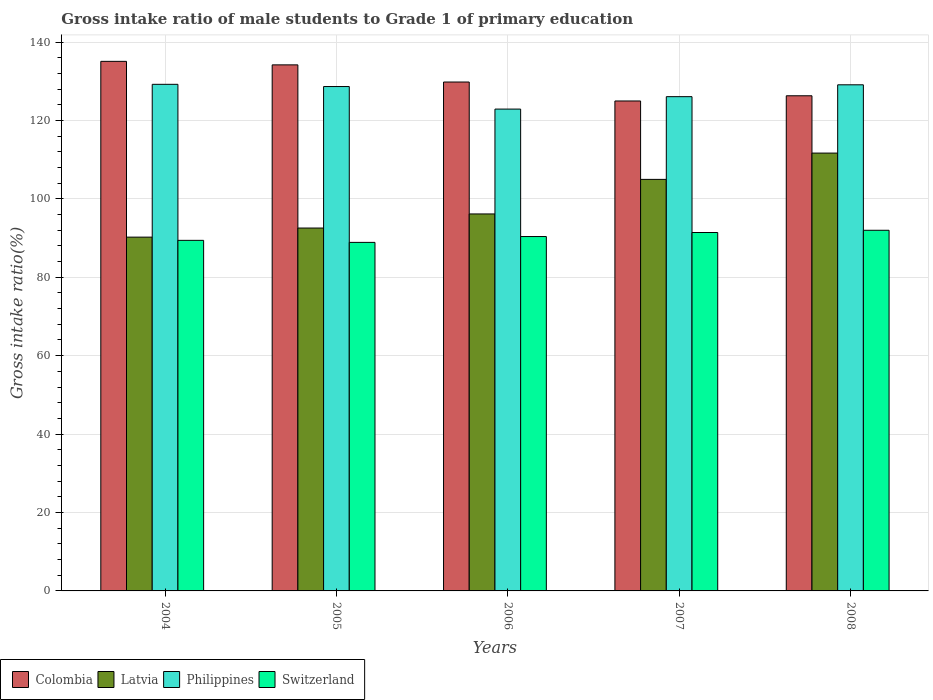Are the number of bars per tick equal to the number of legend labels?
Your answer should be compact. Yes. Are the number of bars on each tick of the X-axis equal?
Provide a succinct answer. Yes. How many bars are there on the 3rd tick from the right?
Ensure brevity in your answer.  4. What is the gross intake ratio in Latvia in 2006?
Provide a short and direct response. 96.15. Across all years, what is the maximum gross intake ratio in Colombia?
Offer a terse response. 135.07. Across all years, what is the minimum gross intake ratio in Colombia?
Offer a very short reply. 124.96. What is the total gross intake ratio in Colombia in the graph?
Provide a succinct answer. 650.29. What is the difference between the gross intake ratio in Latvia in 2006 and that in 2008?
Provide a short and direct response. -15.52. What is the difference between the gross intake ratio in Switzerland in 2007 and the gross intake ratio in Philippines in 2006?
Offer a very short reply. -31.48. What is the average gross intake ratio in Colombia per year?
Make the answer very short. 130.06. In the year 2005, what is the difference between the gross intake ratio in Latvia and gross intake ratio in Colombia?
Offer a terse response. -41.62. In how many years, is the gross intake ratio in Philippines greater than 32 %?
Make the answer very short. 5. What is the ratio of the gross intake ratio in Colombia in 2005 to that in 2007?
Give a very brief answer. 1.07. What is the difference between the highest and the second highest gross intake ratio in Colombia?
Your answer should be very brief. 0.9. What is the difference between the highest and the lowest gross intake ratio in Colombia?
Your answer should be compact. 10.11. In how many years, is the gross intake ratio in Switzerland greater than the average gross intake ratio in Switzerland taken over all years?
Give a very brief answer. 2. What does the 3rd bar from the left in 2005 represents?
Your answer should be compact. Philippines. What does the 1st bar from the right in 2006 represents?
Keep it short and to the point. Switzerland. How many bars are there?
Provide a short and direct response. 20. Are all the bars in the graph horizontal?
Your response must be concise. No. Are the values on the major ticks of Y-axis written in scientific E-notation?
Your answer should be very brief. No. Does the graph contain any zero values?
Give a very brief answer. No. What is the title of the graph?
Your response must be concise. Gross intake ratio of male students to Grade 1 of primary education. Does "China" appear as one of the legend labels in the graph?
Your answer should be very brief. No. What is the label or title of the X-axis?
Offer a terse response. Years. What is the label or title of the Y-axis?
Give a very brief answer. Gross intake ratio(%). What is the Gross intake ratio(%) of Colombia in 2004?
Your answer should be compact. 135.07. What is the Gross intake ratio(%) in Latvia in 2004?
Keep it short and to the point. 90.24. What is the Gross intake ratio(%) in Philippines in 2004?
Make the answer very short. 129.21. What is the Gross intake ratio(%) of Switzerland in 2004?
Keep it short and to the point. 89.42. What is the Gross intake ratio(%) in Colombia in 2005?
Make the answer very short. 134.17. What is the Gross intake ratio(%) in Latvia in 2005?
Provide a short and direct response. 92.55. What is the Gross intake ratio(%) of Philippines in 2005?
Your answer should be compact. 128.65. What is the Gross intake ratio(%) in Switzerland in 2005?
Ensure brevity in your answer.  88.9. What is the Gross intake ratio(%) in Colombia in 2006?
Offer a terse response. 129.8. What is the Gross intake ratio(%) of Latvia in 2006?
Offer a very short reply. 96.15. What is the Gross intake ratio(%) in Philippines in 2006?
Keep it short and to the point. 122.89. What is the Gross intake ratio(%) in Switzerland in 2006?
Give a very brief answer. 90.39. What is the Gross intake ratio(%) in Colombia in 2007?
Your response must be concise. 124.96. What is the Gross intake ratio(%) in Latvia in 2007?
Offer a terse response. 104.97. What is the Gross intake ratio(%) of Philippines in 2007?
Ensure brevity in your answer.  126.06. What is the Gross intake ratio(%) in Switzerland in 2007?
Keep it short and to the point. 91.42. What is the Gross intake ratio(%) of Colombia in 2008?
Your response must be concise. 126.29. What is the Gross intake ratio(%) of Latvia in 2008?
Your response must be concise. 111.67. What is the Gross intake ratio(%) in Philippines in 2008?
Ensure brevity in your answer.  129.09. What is the Gross intake ratio(%) of Switzerland in 2008?
Your response must be concise. 91.99. Across all years, what is the maximum Gross intake ratio(%) of Colombia?
Ensure brevity in your answer.  135.07. Across all years, what is the maximum Gross intake ratio(%) of Latvia?
Ensure brevity in your answer.  111.67. Across all years, what is the maximum Gross intake ratio(%) of Philippines?
Provide a short and direct response. 129.21. Across all years, what is the maximum Gross intake ratio(%) in Switzerland?
Ensure brevity in your answer.  91.99. Across all years, what is the minimum Gross intake ratio(%) of Colombia?
Your answer should be compact. 124.96. Across all years, what is the minimum Gross intake ratio(%) in Latvia?
Offer a terse response. 90.24. Across all years, what is the minimum Gross intake ratio(%) of Philippines?
Offer a very short reply. 122.89. Across all years, what is the minimum Gross intake ratio(%) of Switzerland?
Your answer should be very brief. 88.9. What is the total Gross intake ratio(%) in Colombia in the graph?
Your answer should be very brief. 650.29. What is the total Gross intake ratio(%) in Latvia in the graph?
Ensure brevity in your answer.  495.58. What is the total Gross intake ratio(%) in Philippines in the graph?
Make the answer very short. 635.9. What is the total Gross intake ratio(%) in Switzerland in the graph?
Your response must be concise. 452.1. What is the difference between the Gross intake ratio(%) of Colombia in 2004 and that in 2005?
Make the answer very short. 0.9. What is the difference between the Gross intake ratio(%) in Latvia in 2004 and that in 2005?
Your answer should be compact. -2.32. What is the difference between the Gross intake ratio(%) in Philippines in 2004 and that in 2005?
Provide a succinct answer. 0.57. What is the difference between the Gross intake ratio(%) in Switzerland in 2004 and that in 2005?
Offer a terse response. 0.52. What is the difference between the Gross intake ratio(%) in Colombia in 2004 and that in 2006?
Offer a terse response. 5.27. What is the difference between the Gross intake ratio(%) in Latvia in 2004 and that in 2006?
Offer a very short reply. -5.91. What is the difference between the Gross intake ratio(%) in Philippines in 2004 and that in 2006?
Your answer should be very brief. 6.32. What is the difference between the Gross intake ratio(%) in Switzerland in 2004 and that in 2006?
Provide a succinct answer. -0.97. What is the difference between the Gross intake ratio(%) of Colombia in 2004 and that in 2007?
Provide a succinct answer. 10.11. What is the difference between the Gross intake ratio(%) in Latvia in 2004 and that in 2007?
Your answer should be compact. -14.73. What is the difference between the Gross intake ratio(%) of Philippines in 2004 and that in 2007?
Provide a short and direct response. 3.15. What is the difference between the Gross intake ratio(%) in Switzerland in 2004 and that in 2007?
Offer a very short reply. -2. What is the difference between the Gross intake ratio(%) in Colombia in 2004 and that in 2008?
Ensure brevity in your answer.  8.78. What is the difference between the Gross intake ratio(%) of Latvia in 2004 and that in 2008?
Make the answer very short. -21.44. What is the difference between the Gross intake ratio(%) of Philippines in 2004 and that in 2008?
Your response must be concise. 0.13. What is the difference between the Gross intake ratio(%) in Switzerland in 2004 and that in 2008?
Keep it short and to the point. -2.57. What is the difference between the Gross intake ratio(%) in Colombia in 2005 and that in 2006?
Make the answer very short. 4.38. What is the difference between the Gross intake ratio(%) of Latvia in 2005 and that in 2006?
Ensure brevity in your answer.  -3.6. What is the difference between the Gross intake ratio(%) of Philippines in 2005 and that in 2006?
Give a very brief answer. 5.75. What is the difference between the Gross intake ratio(%) in Switzerland in 2005 and that in 2006?
Provide a short and direct response. -1.49. What is the difference between the Gross intake ratio(%) in Colombia in 2005 and that in 2007?
Your answer should be compact. 9.21. What is the difference between the Gross intake ratio(%) in Latvia in 2005 and that in 2007?
Provide a succinct answer. -12.41. What is the difference between the Gross intake ratio(%) in Philippines in 2005 and that in 2007?
Your answer should be very brief. 2.58. What is the difference between the Gross intake ratio(%) of Switzerland in 2005 and that in 2007?
Offer a very short reply. -2.52. What is the difference between the Gross intake ratio(%) in Colombia in 2005 and that in 2008?
Offer a terse response. 7.88. What is the difference between the Gross intake ratio(%) in Latvia in 2005 and that in 2008?
Give a very brief answer. -19.12. What is the difference between the Gross intake ratio(%) in Philippines in 2005 and that in 2008?
Ensure brevity in your answer.  -0.44. What is the difference between the Gross intake ratio(%) in Switzerland in 2005 and that in 2008?
Your response must be concise. -3.09. What is the difference between the Gross intake ratio(%) of Colombia in 2006 and that in 2007?
Keep it short and to the point. 4.83. What is the difference between the Gross intake ratio(%) in Latvia in 2006 and that in 2007?
Ensure brevity in your answer.  -8.82. What is the difference between the Gross intake ratio(%) in Philippines in 2006 and that in 2007?
Your answer should be very brief. -3.17. What is the difference between the Gross intake ratio(%) of Switzerland in 2006 and that in 2007?
Your answer should be compact. -1.03. What is the difference between the Gross intake ratio(%) in Colombia in 2006 and that in 2008?
Offer a terse response. 3.5. What is the difference between the Gross intake ratio(%) of Latvia in 2006 and that in 2008?
Offer a very short reply. -15.52. What is the difference between the Gross intake ratio(%) in Philippines in 2006 and that in 2008?
Your answer should be compact. -6.19. What is the difference between the Gross intake ratio(%) in Switzerland in 2006 and that in 2008?
Give a very brief answer. -1.6. What is the difference between the Gross intake ratio(%) in Colombia in 2007 and that in 2008?
Your response must be concise. -1.33. What is the difference between the Gross intake ratio(%) in Latvia in 2007 and that in 2008?
Provide a short and direct response. -6.71. What is the difference between the Gross intake ratio(%) in Philippines in 2007 and that in 2008?
Keep it short and to the point. -3.02. What is the difference between the Gross intake ratio(%) of Switzerland in 2007 and that in 2008?
Your answer should be very brief. -0.57. What is the difference between the Gross intake ratio(%) of Colombia in 2004 and the Gross intake ratio(%) of Latvia in 2005?
Ensure brevity in your answer.  42.52. What is the difference between the Gross intake ratio(%) of Colombia in 2004 and the Gross intake ratio(%) of Philippines in 2005?
Your answer should be compact. 6.42. What is the difference between the Gross intake ratio(%) of Colombia in 2004 and the Gross intake ratio(%) of Switzerland in 2005?
Give a very brief answer. 46.17. What is the difference between the Gross intake ratio(%) of Latvia in 2004 and the Gross intake ratio(%) of Philippines in 2005?
Offer a very short reply. -38.41. What is the difference between the Gross intake ratio(%) in Latvia in 2004 and the Gross intake ratio(%) in Switzerland in 2005?
Offer a terse response. 1.34. What is the difference between the Gross intake ratio(%) of Philippines in 2004 and the Gross intake ratio(%) of Switzerland in 2005?
Provide a succinct answer. 40.31. What is the difference between the Gross intake ratio(%) in Colombia in 2004 and the Gross intake ratio(%) in Latvia in 2006?
Give a very brief answer. 38.92. What is the difference between the Gross intake ratio(%) of Colombia in 2004 and the Gross intake ratio(%) of Philippines in 2006?
Make the answer very short. 12.18. What is the difference between the Gross intake ratio(%) of Colombia in 2004 and the Gross intake ratio(%) of Switzerland in 2006?
Offer a very short reply. 44.68. What is the difference between the Gross intake ratio(%) in Latvia in 2004 and the Gross intake ratio(%) in Philippines in 2006?
Give a very brief answer. -32.66. What is the difference between the Gross intake ratio(%) of Latvia in 2004 and the Gross intake ratio(%) of Switzerland in 2006?
Your answer should be very brief. -0.15. What is the difference between the Gross intake ratio(%) of Philippines in 2004 and the Gross intake ratio(%) of Switzerland in 2006?
Make the answer very short. 38.83. What is the difference between the Gross intake ratio(%) in Colombia in 2004 and the Gross intake ratio(%) in Latvia in 2007?
Your response must be concise. 30.1. What is the difference between the Gross intake ratio(%) of Colombia in 2004 and the Gross intake ratio(%) of Philippines in 2007?
Ensure brevity in your answer.  9.01. What is the difference between the Gross intake ratio(%) in Colombia in 2004 and the Gross intake ratio(%) in Switzerland in 2007?
Your answer should be very brief. 43.65. What is the difference between the Gross intake ratio(%) of Latvia in 2004 and the Gross intake ratio(%) of Philippines in 2007?
Ensure brevity in your answer.  -35.83. What is the difference between the Gross intake ratio(%) in Latvia in 2004 and the Gross intake ratio(%) in Switzerland in 2007?
Offer a terse response. -1.18. What is the difference between the Gross intake ratio(%) in Philippines in 2004 and the Gross intake ratio(%) in Switzerland in 2007?
Provide a succinct answer. 37.8. What is the difference between the Gross intake ratio(%) in Colombia in 2004 and the Gross intake ratio(%) in Latvia in 2008?
Offer a very short reply. 23.4. What is the difference between the Gross intake ratio(%) of Colombia in 2004 and the Gross intake ratio(%) of Philippines in 2008?
Your answer should be compact. 5.98. What is the difference between the Gross intake ratio(%) in Colombia in 2004 and the Gross intake ratio(%) in Switzerland in 2008?
Provide a succinct answer. 43.08. What is the difference between the Gross intake ratio(%) in Latvia in 2004 and the Gross intake ratio(%) in Philippines in 2008?
Offer a very short reply. -38.85. What is the difference between the Gross intake ratio(%) of Latvia in 2004 and the Gross intake ratio(%) of Switzerland in 2008?
Provide a succinct answer. -1.75. What is the difference between the Gross intake ratio(%) of Philippines in 2004 and the Gross intake ratio(%) of Switzerland in 2008?
Offer a very short reply. 37.23. What is the difference between the Gross intake ratio(%) of Colombia in 2005 and the Gross intake ratio(%) of Latvia in 2006?
Your answer should be compact. 38.02. What is the difference between the Gross intake ratio(%) in Colombia in 2005 and the Gross intake ratio(%) in Philippines in 2006?
Make the answer very short. 11.28. What is the difference between the Gross intake ratio(%) in Colombia in 2005 and the Gross intake ratio(%) in Switzerland in 2006?
Your answer should be very brief. 43.78. What is the difference between the Gross intake ratio(%) in Latvia in 2005 and the Gross intake ratio(%) in Philippines in 2006?
Offer a very short reply. -30.34. What is the difference between the Gross intake ratio(%) in Latvia in 2005 and the Gross intake ratio(%) in Switzerland in 2006?
Offer a very short reply. 2.17. What is the difference between the Gross intake ratio(%) of Philippines in 2005 and the Gross intake ratio(%) of Switzerland in 2006?
Your response must be concise. 38.26. What is the difference between the Gross intake ratio(%) of Colombia in 2005 and the Gross intake ratio(%) of Latvia in 2007?
Offer a terse response. 29.2. What is the difference between the Gross intake ratio(%) in Colombia in 2005 and the Gross intake ratio(%) in Philippines in 2007?
Your answer should be compact. 8.11. What is the difference between the Gross intake ratio(%) of Colombia in 2005 and the Gross intake ratio(%) of Switzerland in 2007?
Make the answer very short. 42.75. What is the difference between the Gross intake ratio(%) in Latvia in 2005 and the Gross intake ratio(%) in Philippines in 2007?
Provide a succinct answer. -33.51. What is the difference between the Gross intake ratio(%) of Latvia in 2005 and the Gross intake ratio(%) of Switzerland in 2007?
Keep it short and to the point. 1.14. What is the difference between the Gross intake ratio(%) in Philippines in 2005 and the Gross intake ratio(%) in Switzerland in 2007?
Make the answer very short. 37.23. What is the difference between the Gross intake ratio(%) of Colombia in 2005 and the Gross intake ratio(%) of Latvia in 2008?
Make the answer very short. 22.5. What is the difference between the Gross intake ratio(%) in Colombia in 2005 and the Gross intake ratio(%) in Philippines in 2008?
Your answer should be very brief. 5.08. What is the difference between the Gross intake ratio(%) in Colombia in 2005 and the Gross intake ratio(%) in Switzerland in 2008?
Provide a succinct answer. 42.18. What is the difference between the Gross intake ratio(%) of Latvia in 2005 and the Gross intake ratio(%) of Philippines in 2008?
Ensure brevity in your answer.  -36.53. What is the difference between the Gross intake ratio(%) in Latvia in 2005 and the Gross intake ratio(%) in Switzerland in 2008?
Give a very brief answer. 0.57. What is the difference between the Gross intake ratio(%) in Philippines in 2005 and the Gross intake ratio(%) in Switzerland in 2008?
Keep it short and to the point. 36.66. What is the difference between the Gross intake ratio(%) in Colombia in 2006 and the Gross intake ratio(%) in Latvia in 2007?
Offer a terse response. 24.83. What is the difference between the Gross intake ratio(%) of Colombia in 2006 and the Gross intake ratio(%) of Philippines in 2007?
Your answer should be compact. 3.73. What is the difference between the Gross intake ratio(%) of Colombia in 2006 and the Gross intake ratio(%) of Switzerland in 2007?
Give a very brief answer. 38.38. What is the difference between the Gross intake ratio(%) in Latvia in 2006 and the Gross intake ratio(%) in Philippines in 2007?
Provide a short and direct response. -29.91. What is the difference between the Gross intake ratio(%) in Latvia in 2006 and the Gross intake ratio(%) in Switzerland in 2007?
Provide a succinct answer. 4.73. What is the difference between the Gross intake ratio(%) in Philippines in 2006 and the Gross intake ratio(%) in Switzerland in 2007?
Give a very brief answer. 31.48. What is the difference between the Gross intake ratio(%) of Colombia in 2006 and the Gross intake ratio(%) of Latvia in 2008?
Provide a short and direct response. 18.12. What is the difference between the Gross intake ratio(%) of Colombia in 2006 and the Gross intake ratio(%) of Philippines in 2008?
Offer a terse response. 0.71. What is the difference between the Gross intake ratio(%) of Colombia in 2006 and the Gross intake ratio(%) of Switzerland in 2008?
Your answer should be very brief. 37.81. What is the difference between the Gross intake ratio(%) of Latvia in 2006 and the Gross intake ratio(%) of Philippines in 2008?
Provide a short and direct response. -32.94. What is the difference between the Gross intake ratio(%) in Latvia in 2006 and the Gross intake ratio(%) in Switzerland in 2008?
Give a very brief answer. 4.16. What is the difference between the Gross intake ratio(%) in Philippines in 2006 and the Gross intake ratio(%) in Switzerland in 2008?
Your answer should be very brief. 30.91. What is the difference between the Gross intake ratio(%) in Colombia in 2007 and the Gross intake ratio(%) in Latvia in 2008?
Your response must be concise. 13.29. What is the difference between the Gross intake ratio(%) in Colombia in 2007 and the Gross intake ratio(%) in Philippines in 2008?
Make the answer very short. -4.12. What is the difference between the Gross intake ratio(%) in Colombia in 2007 and the Gross intake ratio(%) in Switzerland in 2008?
Make the answer very short. 32.97. What is the difference between the Gross intake ratio(%) in Latvia in 2007 and the Gross intake ratio(%) in Philippines in 2008?
Ensure brevity in your answer.  -24.12. What is the difference between the Gross intake ratio(%) of Latvia in 2007 and the Gross intake ratio(%) of Switzerland in 2008?
Ensure brevity in your answer.  12.98. What is the difference between the Gross intake ratio(%) in Philippines in 2007 and the Gross intake ratio(%) in Switzerland in 2008?
Provide a short and direct response. 34.08. What is the average Gross intake ratio(%) in Colombia per year?
Make the answer very short. 130.06. What is the average Gross intake ratio(%) of Latvia per year?
Your answer should be compact. 99.12. What is the average Gross intake ratio(%) in Philippines per year?
Ensure brevity in your answer.  127.18. What is the average Gross intake ratio(%) of Switzerland per year?
Offer a very short reply. 90.42. In the year 2004, what is the difference between the Gross intake ratio(%) in Colombia and Gross intake ratio(%) in Latvia?
Your response must be concise. 44.83. In the year 2004, what is the difference between the Gross intake ratio(%) in Colombia and Gross intake ratio(%) in Philippines?
Make the answer very short. 5.86. In the year 2004, what is the difference between the Gross intake ratio(%) of Colombia and Gross intake ratio(%) of Switzerland?
Offer a terse response. 45.65. In the year 2004, what is the difference between the Gross intake ratio(%) of Latvia and Gross intake ratio(%) of Philippines?
Your answer should be compact. -38.98. In the year 2004, what is the difference between the Gross intake ratio(%) in Latvia and Gross intake ratio(%) in Switzerland?
Provide a succinct answer. 0.82. In the year 2004, what is the difference between the Gross intake ratio(%) in Philippines and Gross intake ratio(%) in Switzerland?
Offer a very short reply. 39.8. In the year 2005, what is the difference between the Gross intake ratio(%) in Colombia and Gross intake ratio(%) in Latvia?
Ensure brevity in your answer.  41.62. In the year 2005, what is the difference between the Gross intake ratio(%) in Colombia and Gross intake ratio(%) in Philippines?
Your answer should be very brief. 5.53. In the year 2005, what is the difference between the Gross intake ratio(%) in Colombia and Gross intake ratio(%) in Switzerland?
Make the answer very short. 45.27. In the year 2005, what is the difference between the Gross intake ratio(%) of Latvia and Gross intake ratio(%) of Philippines?
Your response must be concise. -36.09. In the year 2005, what is the difference between the Gross intake ratio(%) in Latvia and Gross intake ratio(%) in Switzerland?
Keep it short and to the point. 3.65. In the year 2005, what is the difference between the Gross intake ratio(%) in Philippines and Gross intake ratio(%) in Switzerland?
Ensure brevity in your answer.  39.75. In the year 2006, what is the difference between the Gross intake ratio(%) of Colombia and Gross intake ratio(%) of Latvia?
Offer a very short reply. 33.65. In the year 2006, what is the difference between the Gross intake ratio(%) of Colombia and Gross intake ratio(%) of Philippines?
Your response must be concise. 6.9. In the year 2006, what is the difference between the Gross intake ratio(%) in Colombia and Gross intake ratio(%) in Switzerland?
Offer a very short reply. 39.41. In the year 2006, what is the difference between the Gross intake ratio(%) of Latvia and Gross intake ratio(%) of Philippines?
Your response must be concise. -26.74. In the year 2006, what is the difference between the Gross intake ratio(%) in Latvia and Gross intake ratio(%) in Switzerland?
Your answer should be compact. 5.76. In the year 2006, what is the difference between the Gross intake ratio(%) of Philippines and Gross intake ratio(%) of Switzerland?
Provide a short and direct response. 32.51. In the year 2007, what is the difference between the Gross intake ratio(%) of Colombia and Gross intake ratio(%) of Latvia?
Make the answer very short. 20. In the year 2007, what is the difference between the Gross intake ratio(%) of Colombia and Gross intake ratio(%) of Philippines?
Offer a terse response. -1.1. In the year 2007, what is the difference between the Gross intake ratio(%) in Colombia and Gross intake ratio(%) in Switzerland?
Keep it short and to the point. 33.55. In the year 2007, what is the difference between the Gross intake ratio(%) of Latvia and Gross intake ratio(%) of Philippines?
Offer a very short reply. -21.1. In the year 2007, what is the difference between the Gross intake ratio(%) of Latvia and Gross intake ratio(%) of Switzerland?
Your answer should be very brief. 13.55. In the year 2007, what is the difference between the Gross intake ratio(%) in Philippines and Gross intake ratio(%) in Switzerland?
Provide a short and direct response. 34.65. In the year 2008, what is the difference between the Gross intake ratio(%) in Colombia and Gross intake ratio(%) in Latvia?
Ensure brevity in your answer.  14.62. In the year 2008, what is the difference between the Gross intake ratio(%) of Colombia and Gross intake ratio(%) of Philippines?
Ensure brevity in your answer.  -2.8. In the year 2008, what is the difference between the Gross intake ratio(%) of Colombia and Gross intake ratio(%) of Switzerland?
Offer a very short reply. 34.3. In the year 2008, what is the difference between the Gross intake ratio(%) of Latvia and Gross intake ratio(%) of Philippines?
Make the answer very short. -17.41. In the year 2008, what is the difference between the Gross intake ratio(%) in Latvia and Gross intake ratio(%) in Switzerland?
Give a very brief answer. 19.69. In the year 2008, what is the difference between the Gross intake ratio(%) of Philippines and Gross intake ratio(%) of Switzerland?
Your answer should be compact. 37.1. What is the ratio of the Gross intake ratio(%) of Colombia in 2004 to that in 2005?
Keep it short and to the point. 1.01. What is the ratio of the Gross intake ratio(%) in Switzerland in 2004 to that in 2005?
Offer a very short reply. 1.01. What is the ratio of the Gross intake ratio(%) of Colombia in 2004 to that in 2006?
Your answer should be very brief. 1.04. What is the ratio of the Gross intake ratio(%) of Latvia in 2004 to that in 2006?
Provide a short and direct response. 0.94. What is the ratio of the Gross intake ratio(%) of Philippines in 2004 to that in 2006?
Provide a succinct answer. 1.05. What is the ratio of the Gross intake ratio(%) of Switzerland in 2004 to that in 2006?
Your response must be concise. 0.99. What is the ratio of the Gross intake ratio(%) in Colombia in 2004 to that in 2007?
Provide a short and direct response. 1.08. What is the ratio of the Gross intake ratio(%) in Latvia in 2004 to that in 2007?
Make the answer very short. 0.86. What is the ratio of the Gross intake ratio(%) of Switzerland in 2004 to that in 2007?
Provide a short and direct response. 0.98. What is the ratio of the Gross intake ratio(%) of Colombia in 2004 to that in 2008?
Provide a short and direct response. 1.07. What is the ratio of the Gross intake ratio(%) of Latvia in 2004 to that in 2008?
Provide a succinct answer. 0.81. What is the ratio of the Gross intake ratio(%) in Switzerland in 2004 to that in 2008?
Offer a very short reply. 0.97. What is the ratio of the Gross intake ratio(%) of Colombia in 2005 to that in 2006?
Provide a succinct answer. 1.03. What is the ratio of the Gross intake ratio(%) in Latvia in 2005 to that in 2006?
Give a very brief answer. 0.96. What is the ratio of the Gross intake ratio(%) in Philippines in 2005 to that in 2006?
Keep it short and to the point. 1.05. What is the ratio of the Gross intake ratio(%) of Switzerland in 2005 to that in 2006?
Your answer should be compact. 0.98. What is the ratio of the Gross intake ratio(%) of Colombia in 2005 to that in 2007?
Your response must be concise. 1.07. What is the ratio of the Gross intake ratio(%) of Latvia in 2005 to that in 2007?
Your answer should be compact. 0.88. What is the ratio of the Gross intake ratio(%) of Philippines in 2005 to that in 2007?
Your response must be concise. 1.02. What is the ratio of the Gross intake ratio(%) of Switzerland in 2005 to that in 2007?
Offer a terse response. 0.97. What is the ratio of the Gross intake ratio(%) of Colombia in 2005 to that in 2008?
Ensure brevity in your answer.  1.06. What is the ratio of the Gross intake ratio(%) in Latvia in 2005 to that in 2008?
Your answer should be compact. 0.83. What is the ratio of the Gross intake ratio(%) in Philippines in 2005 to that in 2008?
Keep it short and to the point. 1. What is the ratio of the Gross intake ratio(%) in Switzerland in 2005 to that in 2008?
Your response must be concise. 0.97. What is the ratio of the Gross intake ratio(%) of Colombia in 2006 to that in 2007?
Your answer should be compact. 1.04. What is the ratio of the Gross intake ratio(%) in Latvia in 2006 to that in 2007?
Your response must be concise. 0.92. What is the ratio of the Gross intake ratio(%) in Philippines in 2006 to that in 2007?
Give a very brief answer. 0.97. What is the ratio of the Gross intake ratio(%) in Switzerland in 2006 to that in 2007?
Provide a succinct answer. 0.99. What is the ratio of the Gross intake ratio(%) in Colombia in 2006 to that in 2008?
Give a very brief answer. 1.03. What is the ratio of the Gross intake ratio(%) of Latvia in 2006 to that in 2008?
Your response must be concise. 0.86. What is the ratio of the Gross intake ratio(%) of Philippines in 2006 to that in 2008?
Your response must be concise. 0.95. What is the ratio of the Gross intake ratio(%) of Switzerland in 2006 to that in 2008?
Provide a succinct answer. 0.98. What is the ratio of the Gross intake ratio(%) of Latvia in 2007 to that in 2008?
Offer a terse response. 0.94. What is the ratio of the Gross intake ratio(%) of Philippines in 2007 to that in 2008?
Make the answer very short. 0.98. What is the ratio of the Gross intake ratio(%) in Switzerland in 2007 to that in 2008?
Keep it short and to the point. 0.99. What is the difference between the highest and the second highest Gross intake ratio(%) of Colombia?
Your answer should be compact. 0.9. What is the difference between the highest and the second highest Gross intake ratio(%) of Latvia?
Keep it short and to the point. 6.71. What is the difference between the highest and the second highest Gross intake ratio(%) in Philippines?
Provide a succinct answer. 0.13. What is the difference between the highest and the second highest Gross intake ratio(%) of Switzerland?
Provide a short and direct response. 0.57. What is the difference between the highest and the lowest Gross intake ratio(%) of Colombia?
Offer a terse response. 10.11. What is the difference between the highest and the lowest Gross intake ratio(%) in Latvia?
Offer a very short reply. 21.44. What is the difference between the highest and the lowest Gross intake ratio(%) in Philippines?
Make the answer very short. 6.32. What is the difference between the highest and the lowest Gross intake ratio(%) in Switzerland?
Ensure brevity in your answer.  3.09. 